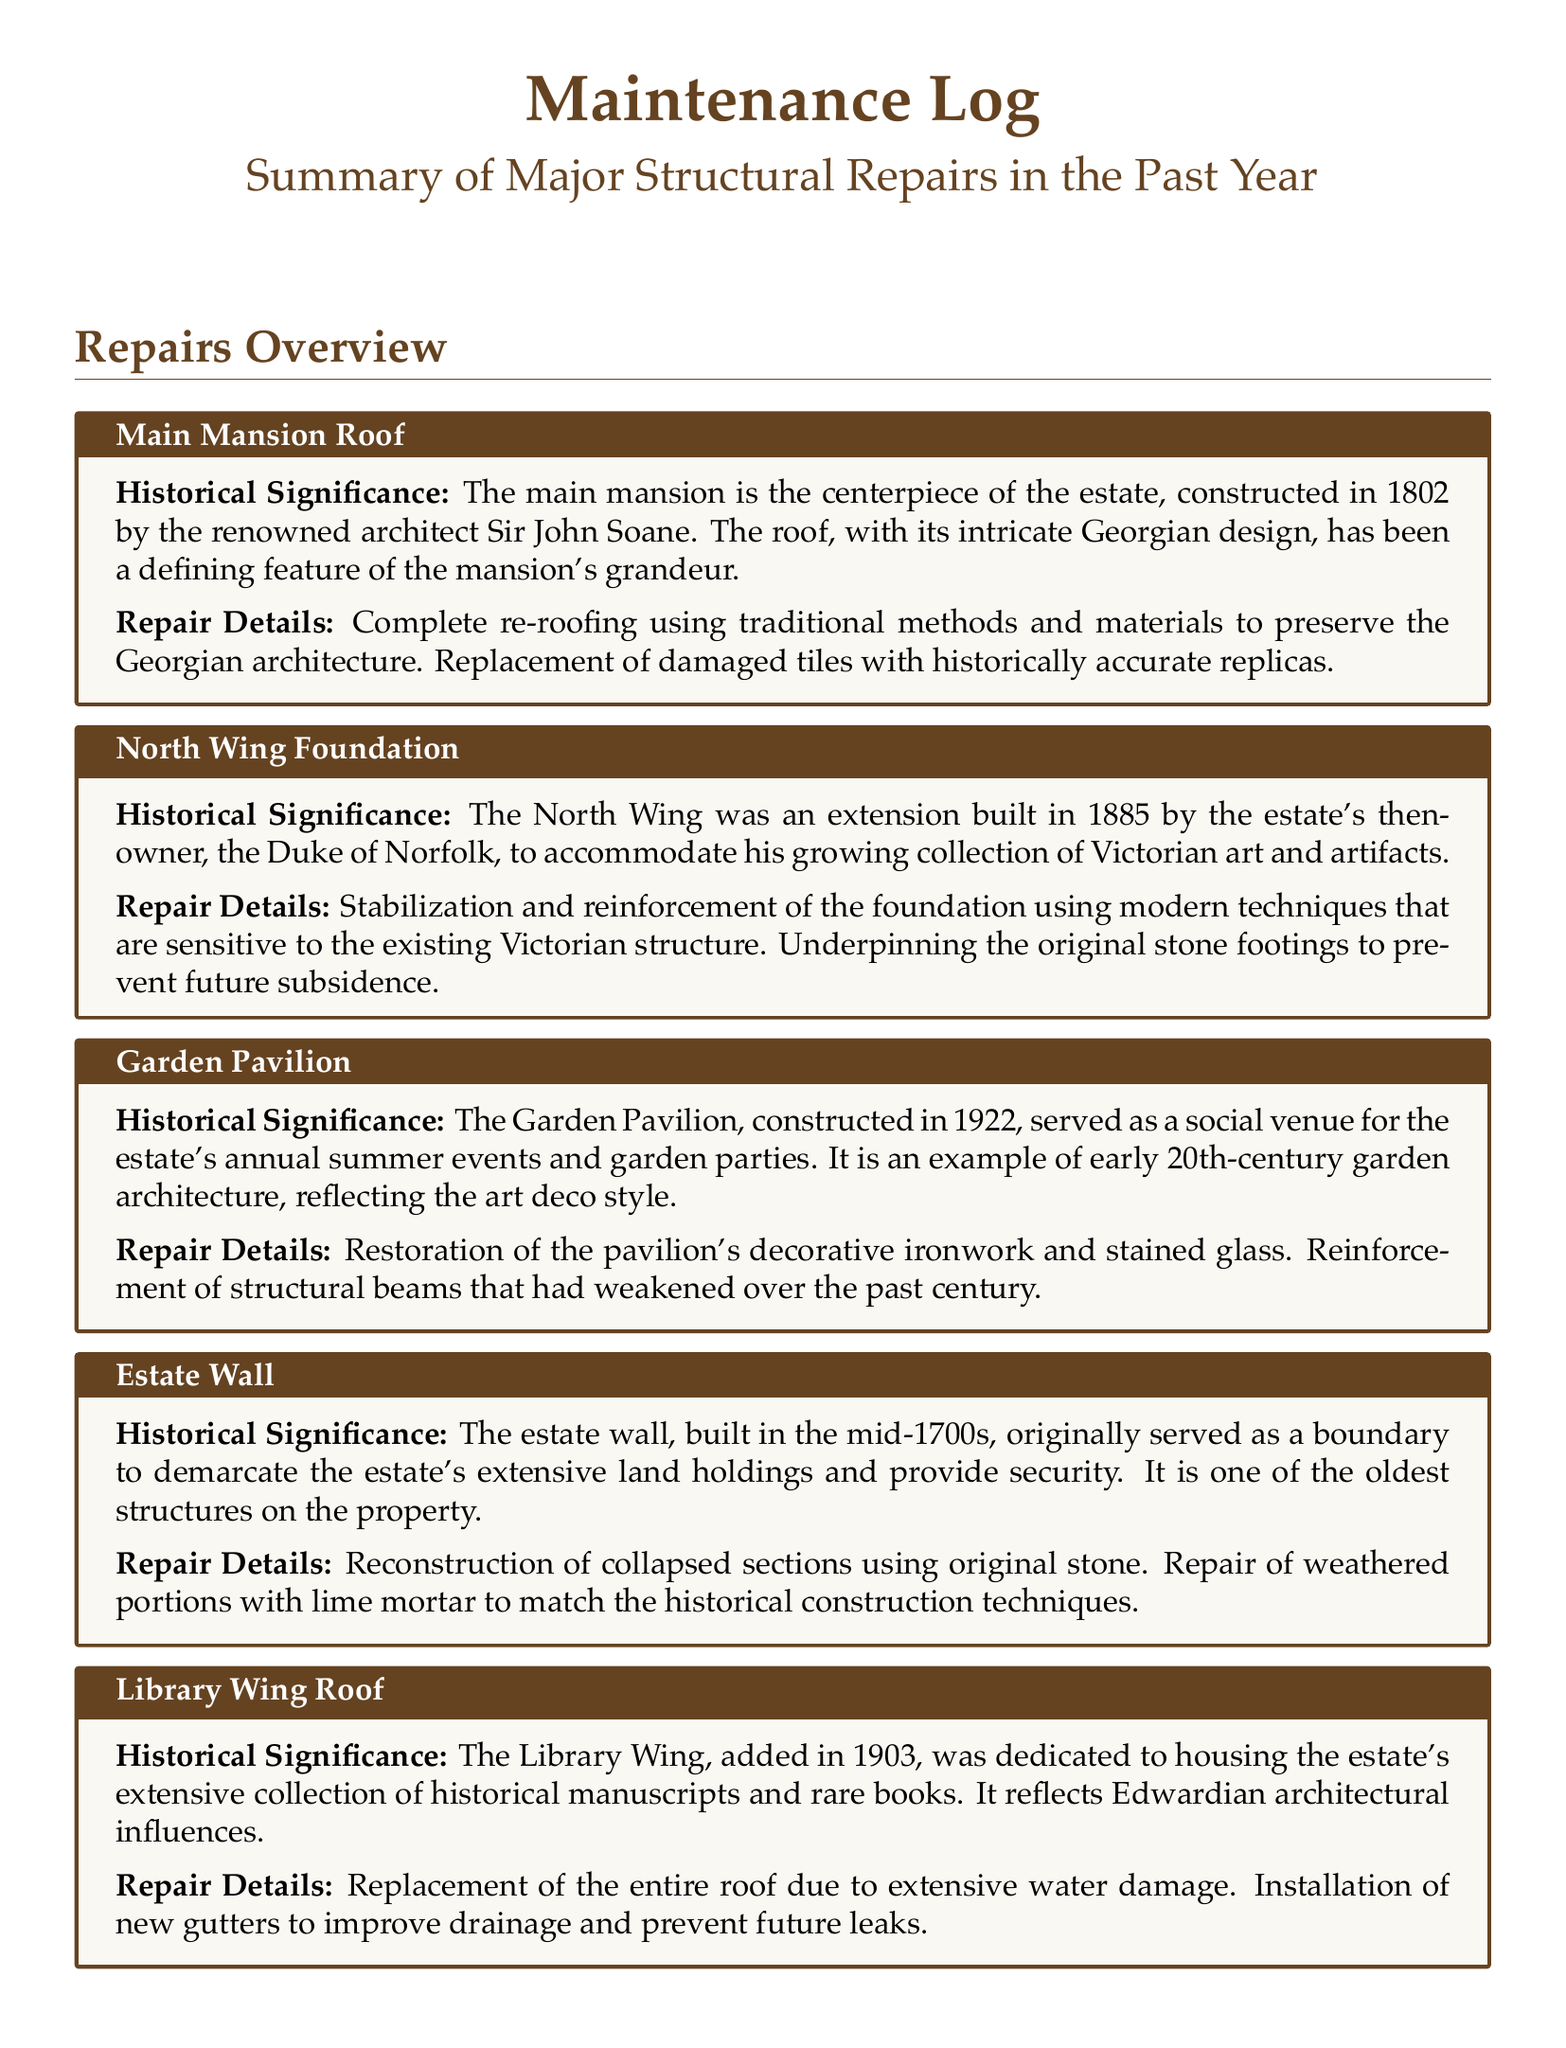What year was the main mansion constructed? The main mansion was constructed in 1802, as stated in the repair item summary.
Answer: 1802 What architectural style does the Garden Pavilion reflect? The Garden Pavilion reflects the art deco style, as mentioned in its historical significance.
Answer: Art deco Who was the owner when the North Wing was built? The North Wing was built by the Duke of Norfolk, as indicated in the repair item details.
Answer: Duke of Norfolk What type of damage necessitated the Library Wing roof replacement? The roof replacement was due to extensive water damage, which is explained in the repair details.
Answer: Water damage What year was the Garden Pavilion constructed? The Garden Pavilion was constructed in 1922, as noted in the repair item summary.
Answer: 1922 What material was used for repairing the estate wall? Lime mortar was used for repairing weathered portions of the estate wall, according to the document.
Answer: Lime mortar Why was the North Wing foundation repaired? The foundation was stabilized to prevent future subsidence, as stated in the repair details.
Answer: Future subsidence Which structure is the oldest on the property? The estate wall, built in the mid-1700s, is the oldest structure on the property.
Answer: Estate wall What historical purpose did the Garden Pavilion serve? The Garden Pavilion served as a social venue for the estate's annual summer events and garden parties.
Answer: Social venue 